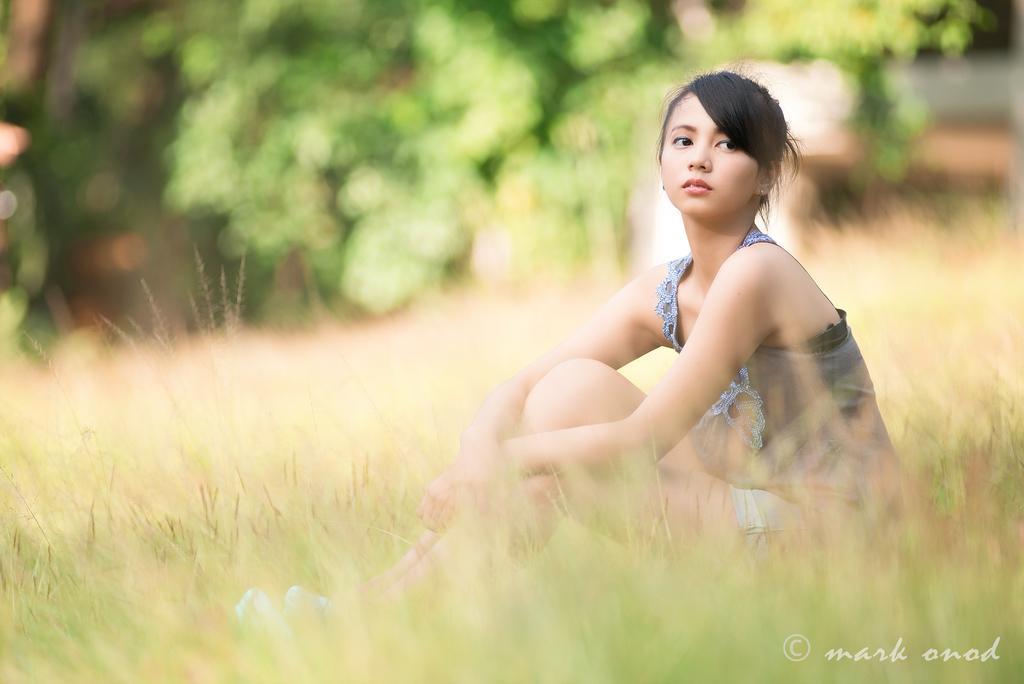How would you summarize this image in a sentence or two? In this image there is a lady sitting on a grass, in the background it is blurred, in the bottom right there is some text. 